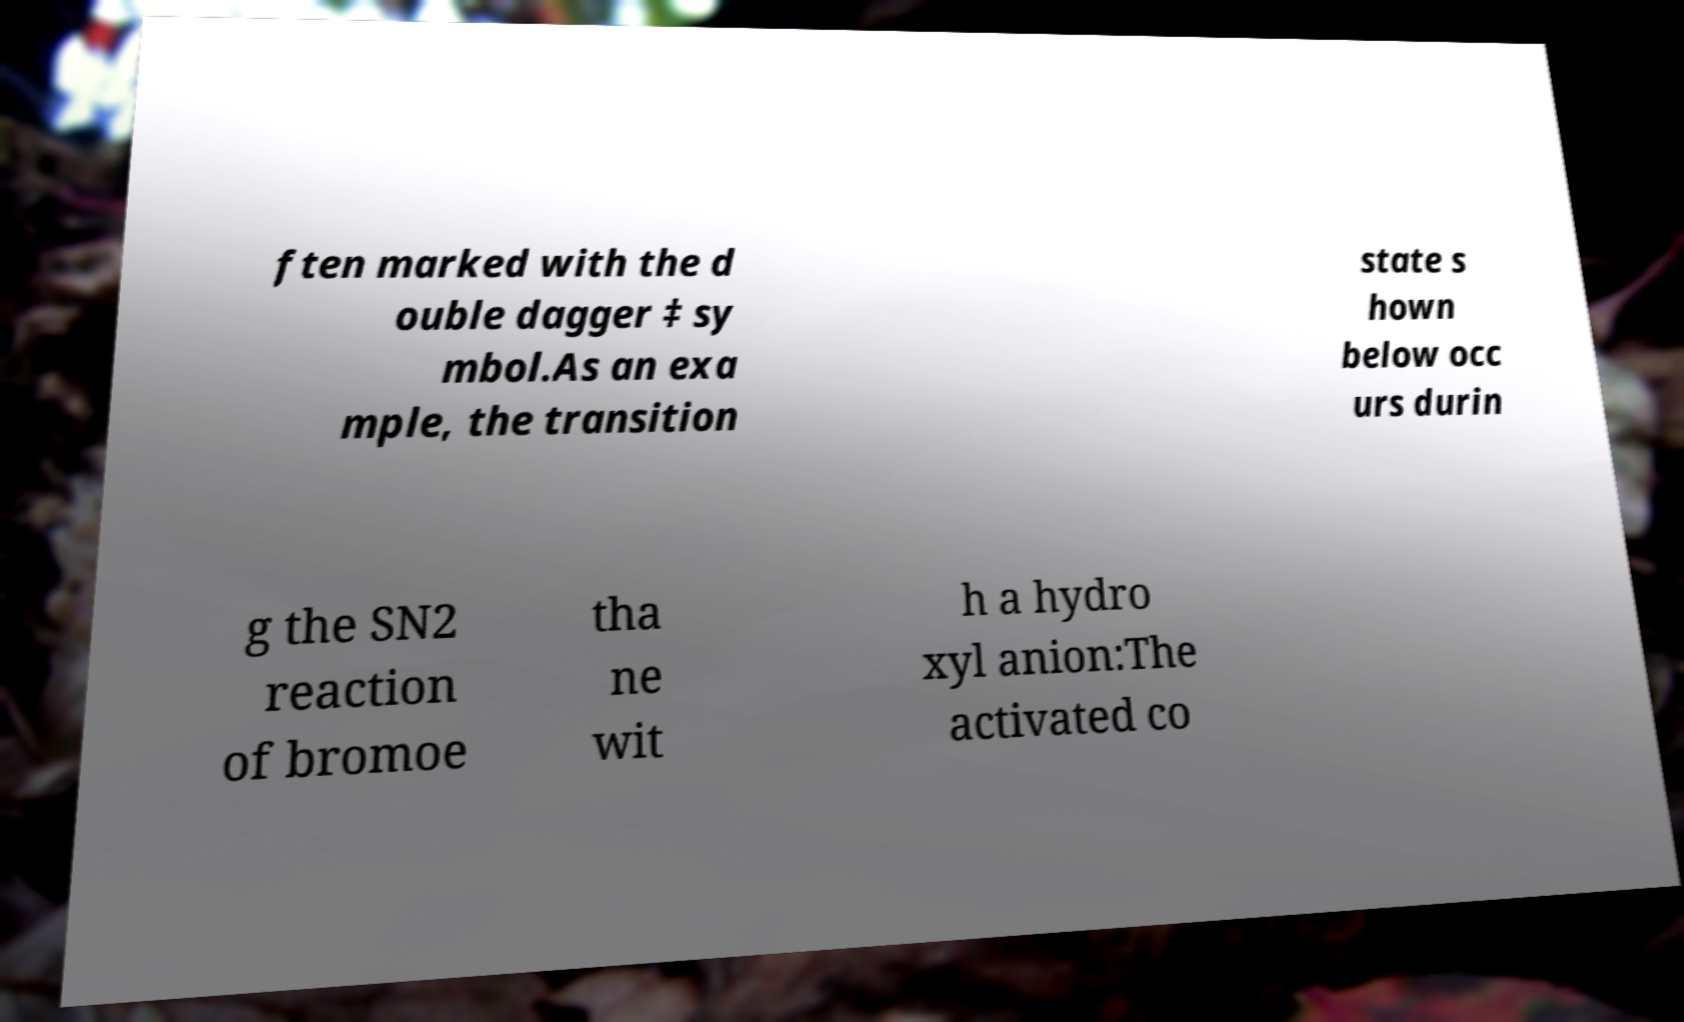For documentation purposes, I need the text within this image transcribed. Could you provide that? ften marked with the d ouble dagger ‡ sy mbol.As an exa mple, the transition state s hown below occ urs durin g the SN2 reaction of bromoe tha ne wit h a hydro xyl anion:The activated co 